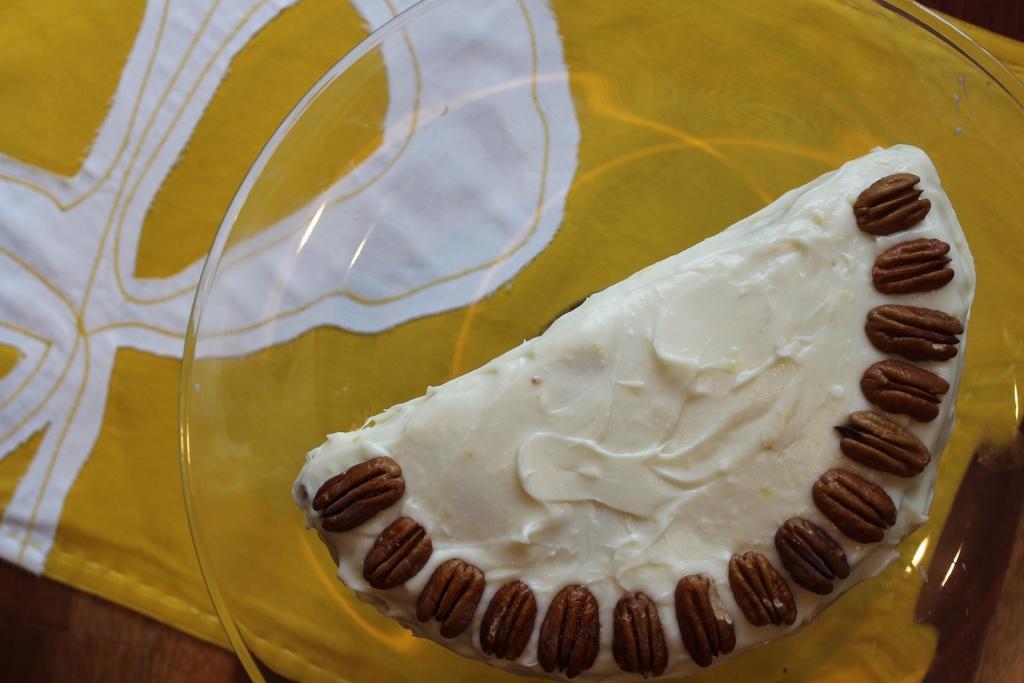Please provide a concise description of this image. In this picture we can see a table. On the table we can see a cloth and a plate which consists of food item. 